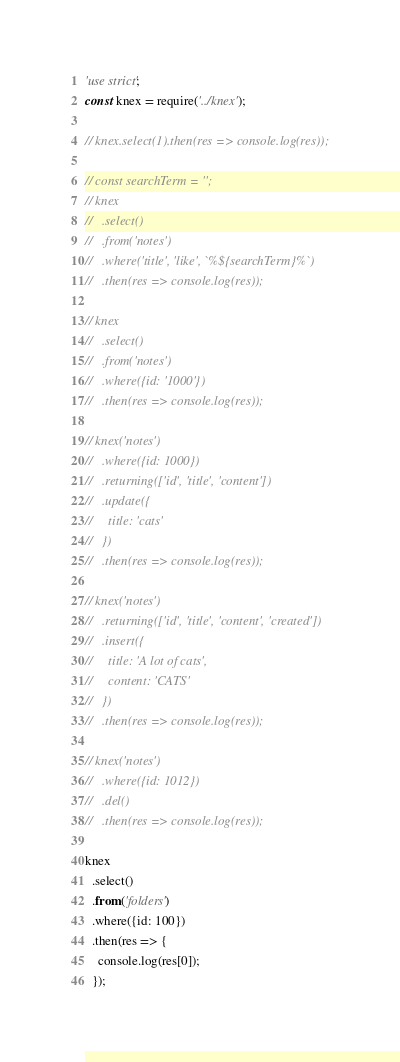<code> <loc_0><loc_0><loc_500><loc_500><_JavaScript_>'use strict';
const knex = require('../knex');

// knex.select(1).then(res => console.log(res));

// const searchTerm = '';
// knex
//   .select()
//   .from('notes')
//   .where('title', 'like', `%${searchTerm}%`)
//   .then(res => console.log(res));

// knex
//   .select()
//   .from('notes')
//   .where({id: '1000'})
//   .then(res => console.log(res));

// knex('notes')
//   .where({id: 1000})
//   .returning(['id', 'title', 'content'])
//   .update({
//     title: 'cats'
//   })
//   .then(res => console.log(res));

// knex('notes')
//   .returning(['id', 'title', 'content', 'created'])
//   .insert({
//     title: 'A lot of cats',
//     content: 'CATS'
//   })
//   .then(res => console.log(res));

// knex('notes')
//   .where({id: 1012})
//   .del()
//   .then(res => console.log(res));

knex
  .select()
  .from('folders')
  .where({id: 100})
  .then(res => {
    console.log(res[0]);
  });</code> 